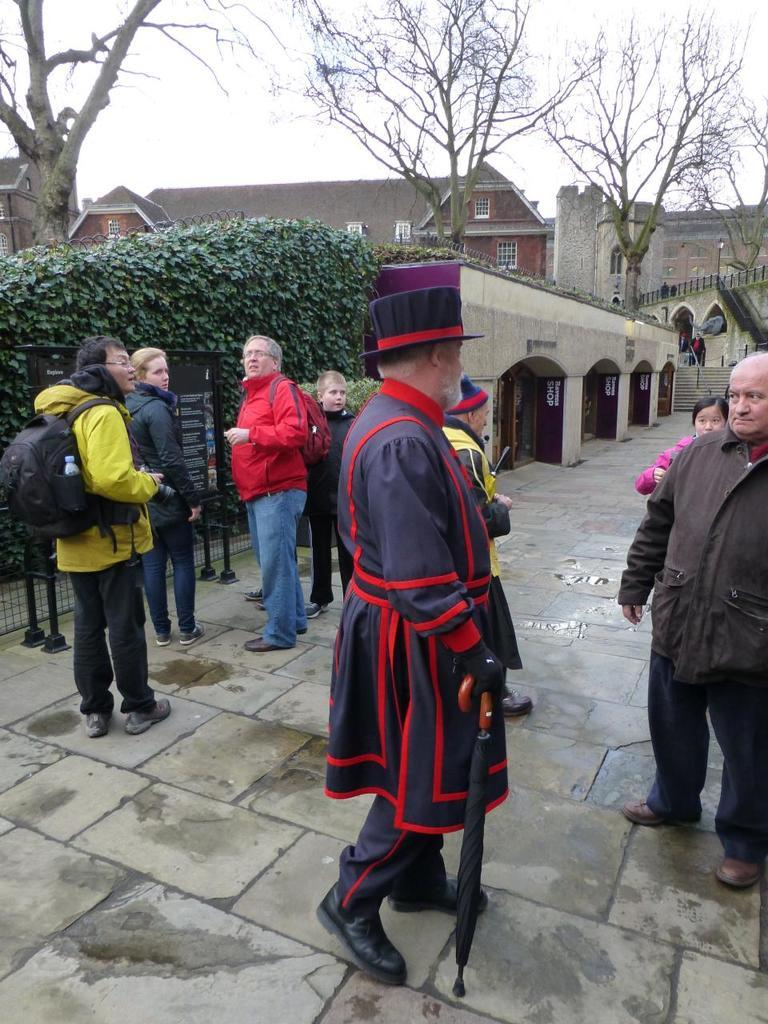Where was the image taken? The image was clicked outside. What type of vegetation can be seen in the image? There are trees and bushes in the image. What type of structures are visible in the image? There are buildings in the image. Are there any people present in the image? Yes, there are persons standing in the image. What is visible at the top of the image? The sky is visible at the top of the image. What is the name of the girl who is not present in the image? There is no girl present in the image, so it is not possible to provide a name. What type of company is responsible for the image? The image is not associated with any company; it is a photograph taken by someone. 